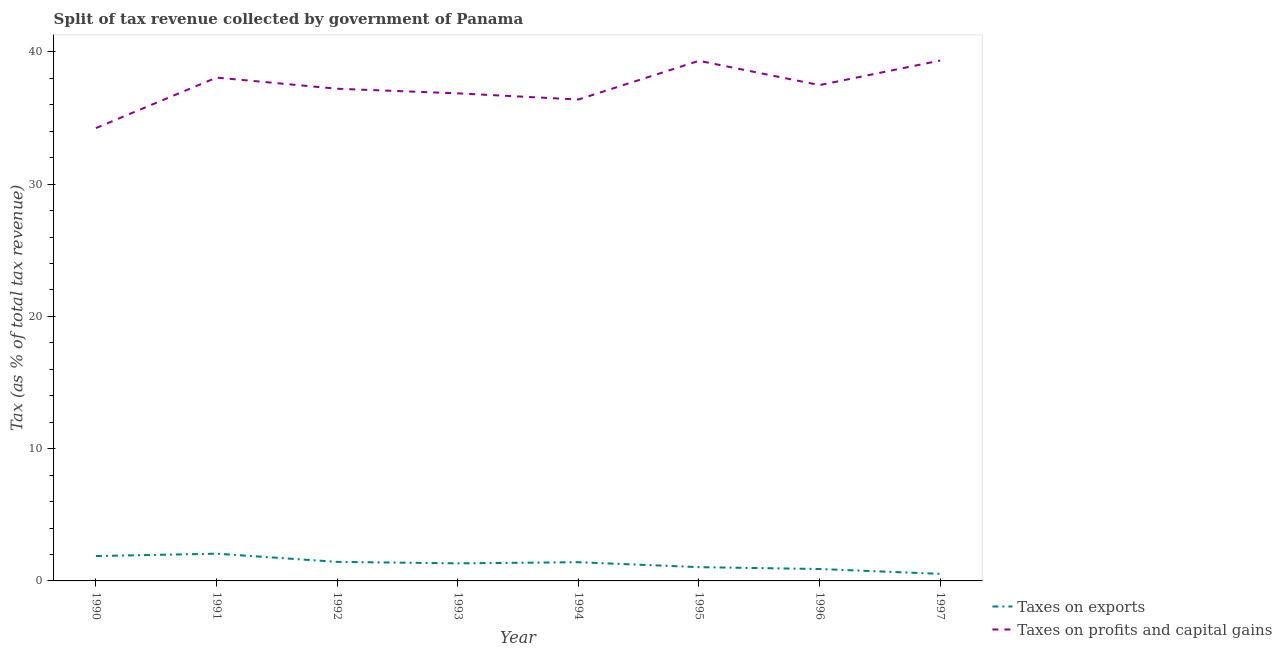Does the line corresponding to percentage of revenue obtained from taxes on profits and capital gains intersect with the line corresponding to percentage of revenue obtained from taxes on exports?
Provide a short and direct response. No. What is the percentage of revenue obtained from taxes on profits and capital gains in 1991?
Give a very brief answer. 38.06. Across all years, what is the maximum percentage of revenue obtained from taxes on exports?
Ensure brevity in your answer.  2.06. Across all years, what is the minimum percentage of revenue obtained from taxes on exports?
Your answer should be very brief. 0.53. In which year was the percentage of revenue obtained from taxes on exports maximum?
Offer a very short reply. 1991. What is the total percentage of revenue obtained from taxes on exports in the graph?
Give a very brief answer. 10.6. What is the difference between the percentage of revenue obtained from taxes on profits and capital gains in 1994 and that in 1996?
Provide a short and direct response. -1.09. What is the difference between the percentage of revenue obtained from taxes on exports in 1994 and the percentage of revenue obtained from taxes on profits and capital gains in 1995?
Give a very brief answer. -37.91. What is the average percentage of revenue obtained from taxes on exports per year?
Offer a very short reply. 1.32. In the year 1997, what is the difference between the percentage of revenue obtained from taxes on exports and percentage of revenue obtained from taxes on profits and capital gains?
Ensure brevity in your answer.  -38.81. In how many years, is the percentage of revenue obtained from taxes on exports greater than 2 %?
Provide a short and direct response. 1. What is the ratio of the percentage of revenue obtained from taxes on exports in 1992 to that in 1996?
Offer a very short reply. 1.6. Is the difference between the percentage of revenue obtained from taxes on profits and capital gains in 1991 and 1993 greater than the difference between the percentage of revenue obtained from taxes on exports in 1991 and 1993?
Provide a succinct answer. Yes. What is the difference between the highest and the second highest percentage of revenue obtained from taxes on profits and capital gains?
Offer a terse response. 0.02. What is the difference between the highest and the lowest percentage of revenue obtained from taxes on exports?
Give a very brief answer. 1.53. In how many years, is the percentage of revenue obtained from taxes on profits and capital gains greater than the average percentage of revenue obtained from taxes on profits and capital gains taken over all years?
Your answer should be compact. 4. Is the sum of the percentage of revenue obtained from taxes on profits and capital gains in 1990 and 1991 greater than the maximum percentage of revenue obtained from taxes on exports across all years?
Give a very brief answer. Yes. Is the percentage of revenue obtained from taxes on exports strictly greater than the percentage of revenue obtained from taxes on profits and capital gains over the years?
Your answer should be compact. No. Is the percentage of revenue obtained from taxes on exports strictly less than the percentage of revenue obtained from taxes on profits and capital gains over the years?
Your answer should be very brief. Yes. How many lines are there?
Offer a terse response. 2. What is the difference between two consecutive major ticks on the Y-axis?
Provide a succinct answer. 10. Does the graph contain any zero values?
Provide a succinct answer. No. Does the graph contain grids?
Your response must be concise. No. Where does the legend appear in the graph?
Keep it short and to the point. Bottom right. How many legend labels are there?
Make the answer very short. 2. How are the legend labels stacked?
Your response must be concise. Vertical. What is the title of the graph?
Provide a short and direct response. Split of tax revenue collected by government of Panama. What is the label or title of the Y-axis?
Your answer should be very brief. Tax (as % of total tax revenue). What is the Tax (as % of total tax revenue) in Taxes on exports in 1990?
Keep it short and to the point. 1.88. What is the Tax (as % of total tax revenue) of Taxes on profits and capital gains in 1990?
Offer a terse response. 34.24. What is the Tax (as % of total tax revenue) of Taxes on exports in 1991?
Make the answer very short. 2.06. What is the Tax (as % of total tax revenue) of Taxes on profits and capital gains in 1991?
Offer a terse response. 38.06. What is the Tax (as % of total tax revenue) in Taxes on exports in 1992?
Give a very brief answer. 1.44. What is the Tax (as % of total tax revenue) of Taxes on profits and capital gains in 1992?
Your answer should be very brief. 37.21. What is the Tax (as % of total tax revenue) in Taxes on exports in 1993?
Provide a short and direct response. 1.33. What is the Tax (as % of total tax revenue) of Taxes on profits and capital gains in 1993?
Keep it short and to the point. 36.86. What is the Tax (as % of total tax revenue) in Taxes on exports in 1994?
Ensure brevity in your answer.  1.41. What is the Tax (as % of total tax revenue) in Taxes on profits and capital gains in 1994?
Ensure brevity in your answer.  36.4. What is the Tax (as % of total tax revenue) in Taxes on exports in 1995?
Ensure brevity in your answer.  1.04. What is the Tax (as % of total tax revenue) of Taxes on profits and capital gains in 1995?
Ensure brevity in your answer.  39.33. What is the Tax (as % of total tax revenue) in Taxes on exports in 1996?
Provide a succinct answer. 0.9. What is the Tax (as % of total tax revenue) in Taxes on profits and capital gains in 1996?
Your response must be concise. 37.49. What is the Tax (as % of total tax revenue) of Taxes on exports in 1997?
Your response must be concise. 0.53. What is the Tax (as % of total tax revenue) of Taxes on profits and capital gains in 1997?
Your answer should be very brief. 39.35. Across all years, what is the maximum Tax (as % of total tax revenue) of Taxes on exports?
Your response must be concise. 2.06. Across all years, what is the maximum Tax (as % of total tax revenue) of Taxes on profits and capital gains?
Give a very brief answer. 39.35. Across all years, what is the minimum Tax (as % of total tax revenue) in Taxes on exports?
Your answer should be very brief. 0.53. Across all years, what is the minimum Tax (as % of total tax revenue) in Taxes on profits and capital gains?
Your answer should be very brief. 34.24. What is the total Tax (as % of total tax revenue) of Taxes on exports in the graph?
Make the answer very short. 10.6. What is the total Tax (as % of total tax revenue) of Taxes on profits and capital gains in the graph?
Ensure brevity in your answer.  298.94. What is the difference between the Tax (as % of total tax revenue) in Taxes on exports in 1990 and that in 1991?
Keep it short and to the point. -0.18. What is the difference between the Tax (as % of total tax revenue) of Taxes on profits and capital gains in 1990 and that in 1991?
Give a very brief answer. -3.82. What is the difference between the Tax (as % of total tax revenue) in Taxes on exports in 1990 and that in 1992?
Provide a succinct answer. 0.44. What is the difference between the Tax (as % of total tax revenue) in Taxes on profits and capital gains in 1990 and that in 1992?
Your answer should be compact. -2.98. What is the difference between the Tax (as % of total tax revenue) in Taxes on exports in 1990 and that in 1993?
Provide a succinct answer. 0.55. What is the difference between the Tax (as % of total tax revenue) of Taxes on profits and capital gains in 1990 and that in 1993?
Give a very brief answer. -2.63. What is the difference between the Tax (as % of total tax revenue) in Taxes on exports in 1990 and that in 1994?
Make the answer very short. 0.47. What is the difference between the Tax (as % of total tax revenue) in Taxes on profits and capital gains in 1990 and that in 1994?
Ensure brevity in your answer.  -2.16. What is the difference between the Tax (as % of total tax revenue) in Taxes on exports in 1990 and that in 1995?
Provide a succinct answer. 0.84. What is the difference between the Tax (as % of total tax revenue) in Taxes on profits and capital gains in 1990 and that in 1995?
Provide a succinct answer. -5.09. What is the difference between the Tax (as % of total tax revenue) in Taxes on profits and capital gains in 1990 and that in 1996?
Offer a very short reply. -3.25. What is the difference between the Tax (as % of total tax revenue) of Taxes on exports in 1990 and that in 1997?
Keep it short and to the point. 1.35. What is the difference between the Tax (as % of total tax revenue) in Taxes on profits and capital gains in 1990 and that in 1997?
Provide a short and direct response. -5.11. What is the difference between the Tax (as % of total tax revenue) of Taxes on exports in 1991 and that in 1992?
Ensure brevity in your answer.  0.62. What is the difference between the Tax (as % of total tax revenue) of Taxes on profits and capital gains in 1991 and that in 1992?
Keep it short and to the point. 0.84. What is the difference between the Tax (as % of total tax revenue) in Taxes on exports in 1991 and that in 1993?
Offer a very short reply. 0.73. What is the difference between the Tax (as % of total tax revenue) in Taxes on profits and capital gains in 1991 and that in 1993?
Your response must be concise. 1.19. What is the difference between the Tax (as % of total tax revenue) in Taxes on exports in 1991 and that in 1994?
Make the answer very short. 0.64. What is the difference between the Tax (as % of total tax revenue) of Taxes on profits and capital gains in 1991 and that in 1994?
Ensure brevity in your answer.  1.66. What is the difference between the Tax (as % of total tax revenue) of Taxes on exports in 1991 and that in 1995?
Your answer should be very brief. 1.02. What is the difference between the Tax (as % of total tax revenue) of Taxes on profits and capital gains in 1991 and that in 1995?
Give a very brief answer. -1.27. What is the difference between the Tax (as % of total tax revenue) of Taxes on exports in 1991 and that in 1996?
Keep it short and to the point. 1.16. What is the difference between the Tax (as % of total tax revenue) of Taxes on profits and capital gains in 1991 and that in 1996?
Provide a succinct answer. 0.57. What is the difference between the Tax (as % of total tax revenue) of Taxes on exports in 1991 and that in 1997?
Your answer should be compact. 1.53. What is the difference between the Tax (as % of total tax revenue) of Taxes on profits and capital gains in 1991 and that in 1997?
Your answer should be compact. -1.29. What is the difference between the Tax (as % of total tax revenue) in Taxes on exports in 1992 and that in 1993?
Your answer should be compact. 0.11. What is the difference between the Tax (as % of total tax revenue) in Taxes on profits and capital gains in 1992 and that in 1993?
Your response must be concise. 0.35. What is the difference between the Tax (as % of total tax revenue) of Taxes on exports in 1992 and that in 1994?
Your answer should be very brief. 0.03. What is the difference between the Tax (as % of total tax revenue) of Taxes on profits and capital gains in 1992 and that in 1994?
Your answer should be compact. 0.82. What is the difference between the Tax (as % of total tax revenue) in Taxes on profits and capital gains in 1992 and that in 1995?
Offer a terse response. -2.11. What is the difference between the Tax (as % of total tax revenue) of Taxes on exports in 1992 and that in 1996?
Your answer should be very brief. 0.54. What is the difference between the Tax (as % of total tax revenue) of Taxes on profits and capital gains in 1992 and that in 1996?
Your response must be concise. -0.27. What is the difference between the Tax (as % of total tax revenue) in Taxes on exports in 1992 and that in 1997?
Keep it short and to the point. 0.91. What is the difference between the Tax (as % of total tax revenue) in Taxes on profits and capital gains in 1992 and that in 1997?
Ensure brevity in your answer.  -2.13. What is the difference between the Tax (as % of total tax revenue) in Taxes on exports in 1993 and that in 1994?
Ensure brevity in your answer.  -0.09. What is the difference between the Tax (as % of total tax revenue) in Taxes on profits and capital gains in 1993 and that in 1994?
Your response must be concise. 0.47. What is the difference between the Tax (as % of total tax revenue) of Taxes on exports in 1993 and that in 1995?
Make the answer very short. 0.29. What is the difference between the Tax (as % of total tax revenue) of Taxes on profits and capital gains in 1993 and that in 1995?
Offer a terse response. -2.46. What is the difference between the Tax (as % of total tax revenue) of Taxes on exports in 1993 and that in 1996?
Offer a very short reply. 0.43. What is the difference between the Tax (as % of total tax revenue) in Taxes on profits and capital gains in 1993 and that in 1996?
Your answer should be very brief. -0.62. What is the difference between the Tax (as % of total tax revenue) in Taxes on exports in 1993 and that in 1997?
Offer a terse response. 0.79. What is the difference between the Tax (as % of total tax revenue) of Taxes on profits and capital gains in 1993 and that in 1997?
Provide a succinct answer. -2.48. What is the difference between the Tax (as % of total tax revenue) of Taxes on exports in 1994 and that in 1995?
Keep it short and to the point. 0.37. What is the difference between the Tax (as % of total tax revenue) in Taxes on profits and capital gains in 1994 and that in 1995?
Your answer should be compact. -2.93. What is the difference between the Tax (as % of total tax revenue) in Taxes on exports in 1994 and that in 1996?
Keep it short and to the point. 0.51. What is the difference between the Tax (as % of total tax revenue) of Taxes on profits and capital gains in 1994 and that in 1996?
Your answer should be compact. -1.09. What is the difference between the Tax (as % of total tax revenue) of Taxes on exports in 1994 and that in 1997?
Offer a terse response. 0.88. What is the difference between the Tax (as % of total tax revenue) of Taxes on profits and capital gains in 1994 and that in 1997?
Your response must be concise. -2.95. What is the difference between the Tax (as % of total tax revenue) of Taxes on exports in 1995 and that in 1996?
Your response must be concise. 0.14. What is the difference between the Tax (as % of total tax revenue) in Taxes on profits and capital gains in 1995 and that in 1996?
Offer a very short reply. 1.84. What is the difference between the Tax (as % of total tax revenue) in Taxes on exports in 1995 and that in 1997?
Offer a very short reply. 0.51. What is the difference between the Tax (as % of total tax revenue) of Taxes on profits and capital gains in 1995 and that in 1997?
Provide a short and direct response. -0.02. What is the difference between the Tax (as % of total tax revenue) in Taxes on exports in 1996 and that in 1997?
Make the answer very short. 0.37. What is the difference between the Tax (as % of total tax revenue) of Taxes on profits and capital gains in 1996 and that in 1997?
Offer a very short reply. -1.86. What is the difference between the Tax (as % of total tax revenue) in Taxes on exports in 1990 and the Tax (as % of total tax revenue) in Taxes on profits and capital gains in 1991?
Offer a very short reply. -36.18. What is the difference between the Tax (as % of total tax revenue) of Taxes on exports in 1990 and the Tax (as % of total tax revenue) of Taxes on profits and capital gains in 1992?
Give a very brief answer. -35.33. What is the difference between the Tax (as % of total tax revenue) in Taxes on exports in 1990 and the Tax (as % of total tax revenue) in Taxes on profits and capital gains in 1993?
Your answer should be very brief. -34.98. What is the difference between the Tax (as % of total tax revenue) in Taxes on exports in 1990 and the Tax (as % of total tax revenue) in Taxes on profits and capital gains in 1994?
Ensure brevity in your answer.  -34.52. What is the difference between the Tax (as % of total tax revenue) of Taxes on exports in 1990 and the Tax (as % of total tax revenue) of Taxes on profits and capital gains in 1995?
Make the answer very short. -37.45. What is the difference between the Tax (as % of total tax revenue) in Taxes on exports in 1990 and the Tax (as % of total tax revenue) in Taxes on profits and capital gains in 1996?
Your answer should be compact. -35.61. What is the difference between the Tax (as % of total tax revenue) in Taxes on exports in 1990 and the Tax (as % of total tax revenue) in Taxes on profits and capital gains in 1997?
Your answer should be very brief. -37.47. What is the difference between the Tax (as % of total tax revenue) of Taxes on exports in 1991 and the Tax (as % of total tax revenue) of Taxes on profits and capital gains in 1992?
Your answer should be very brief. -35.16. What is the difference between the Tax (as % of total tax revenue) of Taxes on exports in 1991 and the Tax (as % of total tax revenue) of Taxes on profits and capital gains in 1993?
Your response must be concise. -34.81. What is the difference between the Tax (as % of total tax revenue) in Taxes on exports in 1991 and the Tax (as % of total tax revenue) in Taxes on profits and capital gains in 1994?
Your answer should be compact. -34.34. What is the difference between the Tax (as % of total tax revenue) in Taxes on exports in 1991 and the Tax (as % of total tax revenue) in Taxes on profits and capital gains in 1995?
Ensure brevity in your answer.  -37.27. What is the difference between the Tax (as % of total tax revenue) of Taxes on exports in 1991 and the Tax (as % of total tax revenue) of Taxes on profits and capital gains in 1996?
Offer a terse response. -35.43. What is the difference between the Tax (as % of total tax revenue) in Taxes on exports in 1991 and the Tax (as % of total tax revenue) in Taxes on profits and capital gains in 1997?
Your response must be concise. -37.29. What is the difference between the Tax (as % of total tax revenue) of Taxes on exports in 1992 and the Tax (as % of total tax revenue) of Taxes on profits and capital gains in 1993?
Provide a succinct answer. -35.42. What is the difference between the Tax (as % of total tax revenue) in Taxes on exports in 1992 and the Tax (as % of total tax revenue) in Taxes on profits and capital gains in 1994?
Provide a succinct answer. -34.96. What is the difference between the Tax (as % of total tax revenue) in Taxes on exports in 1992 and the Tax (as % of total tax revenue) in Taxes on profits and capital gains in 1995?
Your answer should be compact. -37.89. What is the difference between the Tax (as % of total tax revenue) of Taxes on exports in 1992 and the Tax (as % of total tax revenue) of Taxes on profits and capital gains in 1996?
Give a very brief answer. -36.05. What is the difference between the Tax (as % of total tax revenue) of Taxes on exports in 1992 and the Tax (as % of total tax revenue) of Taxes on profits and capital gains in 1997?
Give a very brief answer. -37.9. What is the difference between the Tax (as % of total tax revenue) in Taxes on exports in 1993 and the Tax (as % of total tax revenue) in Taxes on profits and capital gains in 1994?
Provide a short and direct response. -35.07. What is the difference between the Tax (as % of total tax revenue) of Taxes on exports in 1993 and the Tax (as % of total tax revenue) of Taxes on profits and capital gains in 1995?
Give a very brief answer. -38. What is the difference between the Tax (as % of total tax revenue) of Taxes on exports in 1993 and the Tax (as % of total tax revenue) of Taxes on profits and capital gains in 1996?
Your response must be concise. -36.16. What is the difference between the Tax (as % of total tax revenue) in Taxes on exports in 1993 and the Tax (as % of total tax revenue) in Taxes on profits and capital gains in 1997?
Make the answer very short. -38.02. What is the difference between the Tax (as % of total tax revenue) in Taxes on exports in 1994 and the Tax (as % of total tax revenue) in Taxes on profits and capital gains in 1995?
Your answer should be compact. -37.91. What is the difference between the Tax (as % of total tax revenue) of Taxes on exports in 1994 and the Tax (as % of total tax revenue) of Taxes on profits and capital gains in 1996?
Offer a terse response. -36.07. What is the difference between the Tax (as % of total tax revenue) in Taxes on exports in 1994 and the Tax (as % of total tax revenue) in Taxes on profits and capital gains in 1997?
Keep it short and to the point. -37.93. What is the difference between the Tax (as % of total tax revenue) of Taxes on exports in 1995 and the Tax (as % of total tax revenue) of Taxes on profits and capital gains in 1996?
Keep it short and to the point. -36.45. What is the difference between the Tax (as % of total tax revenue) in Taxes on exports in 1995 and the Tax (as % of total tax revenue) in Taxes on profits and capital gains in 1997?
Your answer should be very brief. -38.3. What is the difference between the Tax (as % of total tax revenue) of Taxes on exports in 1996 and the Tax (as % of total tax revenue) of Taxes on profits and capital gains in 1997?
Your answer should be very brief. -38.45. What is the average Tax (as % of total tax revenue) in Taxes on exports per year?
Your answer should be very brief. 1.32. What is the average Tax (as % of total tax revenue) in Taxes on profits and capital gains per year?
Your answer should be compact. 37.37. In the year 1990, what is the difference between the Tax (as % of total tax revenue) in Taxes on exports and Tax (as % of total tax revenue) in Taxes on profits and capital gains?
Give a very brief answer. -32.36. In the year 1991, what is the difference between the Tax (as % of total tax revenue) in Taxes on exports and Tax (as % of total tax revenue) in Taxes on profits and capital gains?
Keep it short and to the point. -36. In the year 1992, what is the difference between the Tax (as % of total tax revenue) of Taxes on exports and Tax (as % of total tax revenue) of Taxes on profits and capital gains?
Your answer should be very brief. -35.77. In the year 1993, what is the difference between the Tax (as % of total tax revenue) of Taxes on exports and Tax (as % of total tax revenue) of Taxes on profits and capital gains?
Your answer should be compact. -35.54. In the year 1994, what is the difference between the Tax (as % of total tax revenue) in Taxes on exports and Tax (as % of total tax revenue) in Taxes on profits and capital gains?
Provide a succinct answer. -34.98. In the year 1995, what is the difference between the Tax (as % of total tax revenue) in Taxes on exports and Tax (as % of total tax revenue) in Taxes on profits and capital gains?
Give a very brief answer. -38.29. In the year 1996, what is the difference between the Tax (as % of total tax revenue) in Taxes on exports and Tax (as % of total tax revenue) in Taxes on profits and capital gains?
Make the answer very short. -36.59. In the year 1997, what is the difference between the Tax (as % of total tax revenue) in Taxes on exports and Tax (as % of total tax revenue) in Taxes on profits and capital gains?
Ensure brevity in your answer.  -38.81. What is the ratio of the Tax (as % of total tax revenue) of Taxes on exports in 1990 to that in 1991?
Your answer should be compact. 0.91. What is the ratio of the Tax (as % of total tax revenue) in Taxes on profits and capital gains in 1990 to that in 1991?
Offer a very short reply. 0.9. What is the ratio of the Tax (as % of total tax revenue) in Taxes on exports in 1990 to that in 1992?
Make the answer very short. 1.3. What is the ratio of the Tax (as % of total tax revenue) in Taxes on exports in 1990 to that in 1993?
Your answer should be compact. 1.42. What is the ratio of the Tax (as % of total tax revenue) of Taxes on profits and capital gains in 1990 to that in 1993?
Your answer should be compact. 0.93. What is the ratio of the Tax (as % of total tax revenue) in Taxes on exports in 1990 to that in 1994?
Make the answer very short. 1.33. What is the ratio of the Tax (as % of total tax revenue) of Taxes on profits and capital gains in 1990 to that in 1994?
Offer a terse response. 0.94. What is the ratio of the Tax (as % of total tax revenue) in Taxes on exports in 1990 to that in 1995?
Offer a terse response. 1.81. What is the ratio of the Tax (as % of total tax revenue) of Taxes on profits and capital gains in 1990 to that in 1995?
Your answer should be compact. 0.87. What is the ratio of the Tax (as % of total tax revenue) in Taxes on exports in 1990 to that in 1996?
Offer a terse response. 2.09. What is the ratio of the Tax (as % of total tax revenue) in Taxes on profits and capital gains in 1990 to that in 1996?
Your response must be concise. 0.91. What is the ratio of the Tax (as % of total tax revenue) in Taxes on exports in 1990 to that in 1997?
Ensure brevity in your answer.  3.52. What is the ratio of the Tax (as % of total tax revenue) in Taxes on profits and capital gains in 1990 to that in 1997?
Provide a short and direct response. 0.87. What is the ratio of the Tax (as % of total tax revenue) of Taxes on exports in 1991 to that in 1992?
Provide a succinct answer. 1.43. What is the ratio of the Tax (as % of total tax revenue) of Taxes on profits and capital gains in 1991 to that in 1992?
Your answer should be very brief. 1.02. What is the ratio of the Tax (as % of total tax revenue) of Taxes on exports in 1991 to that in 1993?
Ensure brevity in your answer.  1.55. What is the ratio of the Tax (as % of total tax revenue) of Taxes on profits and capital gains in 1991 to that in 1993?
Your response must be concise. 1.03. What is the ratio of the Tax (as % of total tax revenue) in Taxes on exports in 1991 to that in 1994?
Provide a succinct answer. 1.46. What is the ratio of the Tax (as % of total tax revenue) of Taxes on profits and capital gains in 1991 to that in 1994?
Your answer should be compact. 1.05. What is the ratio of the Tax (as % of total tax revenue) of Taxes on exports in 1991 to that in 1995?
Give a very brief answer. 1.98. What is the ratio of the Tax (as % of total tax revenue) in Taxes on profits and capital gains in 1991 to that in 1995?
Ensure brevity in your answer.  0.97. What is the ratio of the Tax (as % of total tax revenue) in Taxes on exports in 1991 to that in 1996?
Make the answer very short. 2.29. What is the ratio of the Tax (as % of total tax revenue) of Taxes on profits and capital gains in 1991 to that in 1996?
Your response must be concise. 1.02. What is the ratio of the Tax (as % of total tax revenue) in Taxes on exports in 1991 to that in 1997?
Offer a terse response. 3.86. What is the ratio of the Tax (as % of total tax revenue) of Taxes on profits and capital gains in 1991 to that in 1997?
Ensure brevity in your answer.  0.97. What is the ratio of the Tax (as % of total tax revenue) of Taxes on exports in 1992 to that in 1993?
Provide a succinct answer. 1.08. What is the ratio of the Tax (as % of total tax revenue) in Taxes on profits and capital gains in 1992 to that in 1993?
Your answer should be very brief. 1.01. What is the ratio of the Tax (as % of total tax revenue) of Taxes on exports in 1992 to that in 1994?
Your response must be concise. 1.02. What is the ratio of the Tax (as % of total tax revenue) in Taxes on profits and capital gains in 1992 to that in 1994?
Offer a terse response. 1.02. What is the ratio of the Tax (as % of total tax revenue) of Taxes on exports in 1992 to that in 1995?
Your response must be concise. 1.38. What is the ratio of the Tax (as % of total tax revenue) in Taxes on profits and capital gains in 1992 to that in 1995?
Keep it short and to the point. 0.95. What is the ratio of the Tax (as % of total tax revenue) of Taxes on exports in 1992 to that in 1996?
Provide a short and direct response. 1.6. What is the ratio of the Tax (as % of total tax revenue) of Taxes on exports in 1992 to that in 1997?
Your answer should be very brief. 2.7. What is the ratio of the Tax (as % of total tax revenue) of Taxes on profits and capital gains in 1992 to that in 1997?
Ensure brevity in your answer.  0.95. What is the ratio of the Tax (as % of total tax revenue) of Taxes on exports in 1993 to that in 1994?
Offer a very short reply. 0.94. What is the ratio of the Tax (as % of total tax revenue) of Taxes on profits and capital gains in 1993 to that in 1994?
Offer a very short reply. 1.01. What is the ratio of the Tax (as % of total tax revenue) in Taxes on exports in 1993 to that in 1995?
Provide a succinct answer. 1.28. What is the ratio of the Tax (as % of total tax revenue) in Taxes on profits and capital gains in 1993 to that in 1995?
Offer a terse response. 0.94. What is the ratio of the Tax (as % of total tax revenue) in Taxes on exports in 1993 to that in 1996?
Offer a terse response. 1.48. What is the ratio of the Tax (as % of total tax revenue) in Taxes on profits and capital gains in 1993 to that in 1996?
Your response must be concise. 0.98. What is the ratio of the Tax (as % of total tax revenue) of Taxes on exports in 1993 to that in 1997?
Your answer should be compact. 2.49. What is the ratio of the Tax (as % of total tax revenue) in Taxes on profits and capital gains in 1993 to that in 1997?
Offer a terse response. 0.94. What is the ratio of the Tax (as % of total tax revenue) of Taxes on exports in 1994 to that in 1995?
Give a very brief answer. 1.36. What is the ratio of the Tax (as % of total tax revenue) of Taxes on profits and capital gains in 1994 to that in 1995?
Make the answer very short. 0.93. What is the ratio of the Tax (as % of total tax revenue) in Taxes on exports in 1994 to that in 1996?
Your answer should be compact. 1.57. What is the ratio of the Tax (as % of total tax revenue) of Taxes on profits and capital gains in 1994 to that in 1996?
Keep it short and to the point. 0.97. What is the ratio of the Tax (as % of total tax revenue) in Taxes on exports in 1994 to that in 1997?
Provide a succinct answer. 2.65. What is the ratio of the Tax (as % of total tax revenue) of Taxes on profits and capital gains in 1994 to that in 1997?
Your response must be concise. 0.93. What is the ratio of the Tax (as % of total tax revenue) in Taxes on exports in 1995 to that in 1996?
Make the answer very short. 1.16. What is the ratio of the Tax (as % of total tax revenue) in Taxes on profits and capital gains in 1995 to that in 1996?
Give a very brief answer. 1.05. What is the ratio of the Tax (as % of total tax revenue) in Taxes on exports in 1995 to that in 1997?
Keep it short and to the point. 1.95. What is the ratio of the Tax (as % of total tax revenue) in Taxes on profits and capital gains in 1995 to that in 1997?
Offer a very short reply. 1. What is the ratio of the Tax (as % of total tax revenue) in Taxes on exports in 1996 to that in 1997?
Provide a short and direct response. 1.69. What is the ratio of the Tax (as % of total tax revenue) of Taxes on profits and capital gains in 1996 to that in 1997?
Keep it short and to the point. 0.95. What is the difference between the highest and the second highest Tax (as % of total tax revenue) in Taxes on exports?
Keep it short and to the point. 0.18. What is the difference between the highest and the second highest Tax (as % of total tax revenue) in Taxes on profits and capital gains?
Provide a short and direct response. 0.02. What is the difference between the highest and the lowest Tax (as % of total tax revenue) in Taxes on exports?
Provide a succinct answer. 1.53. What is the difference between the highest and the lowest Tax (as % of total tax revenue) of Taxes on profits and capital gains?
Make the answer very short. 5.11. 